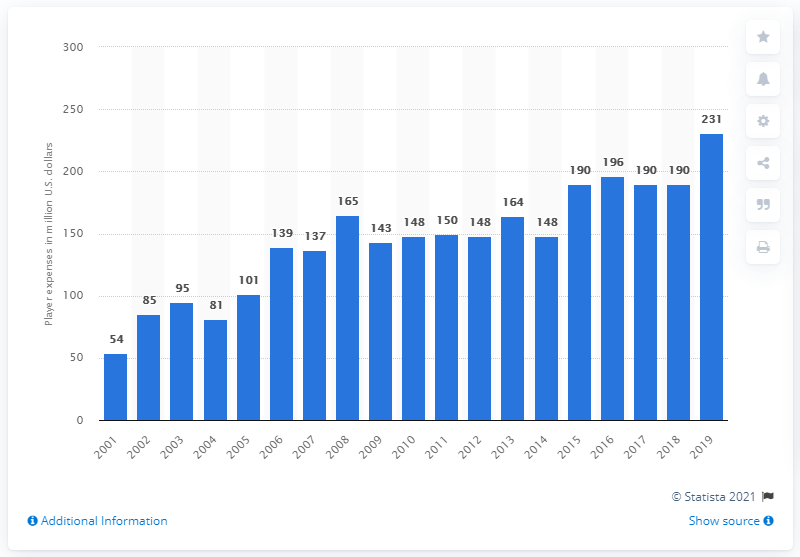Specify some key components in this picture. The player expenses of the Dallas Cowboys in the 2019 season were 231 million dollars. 